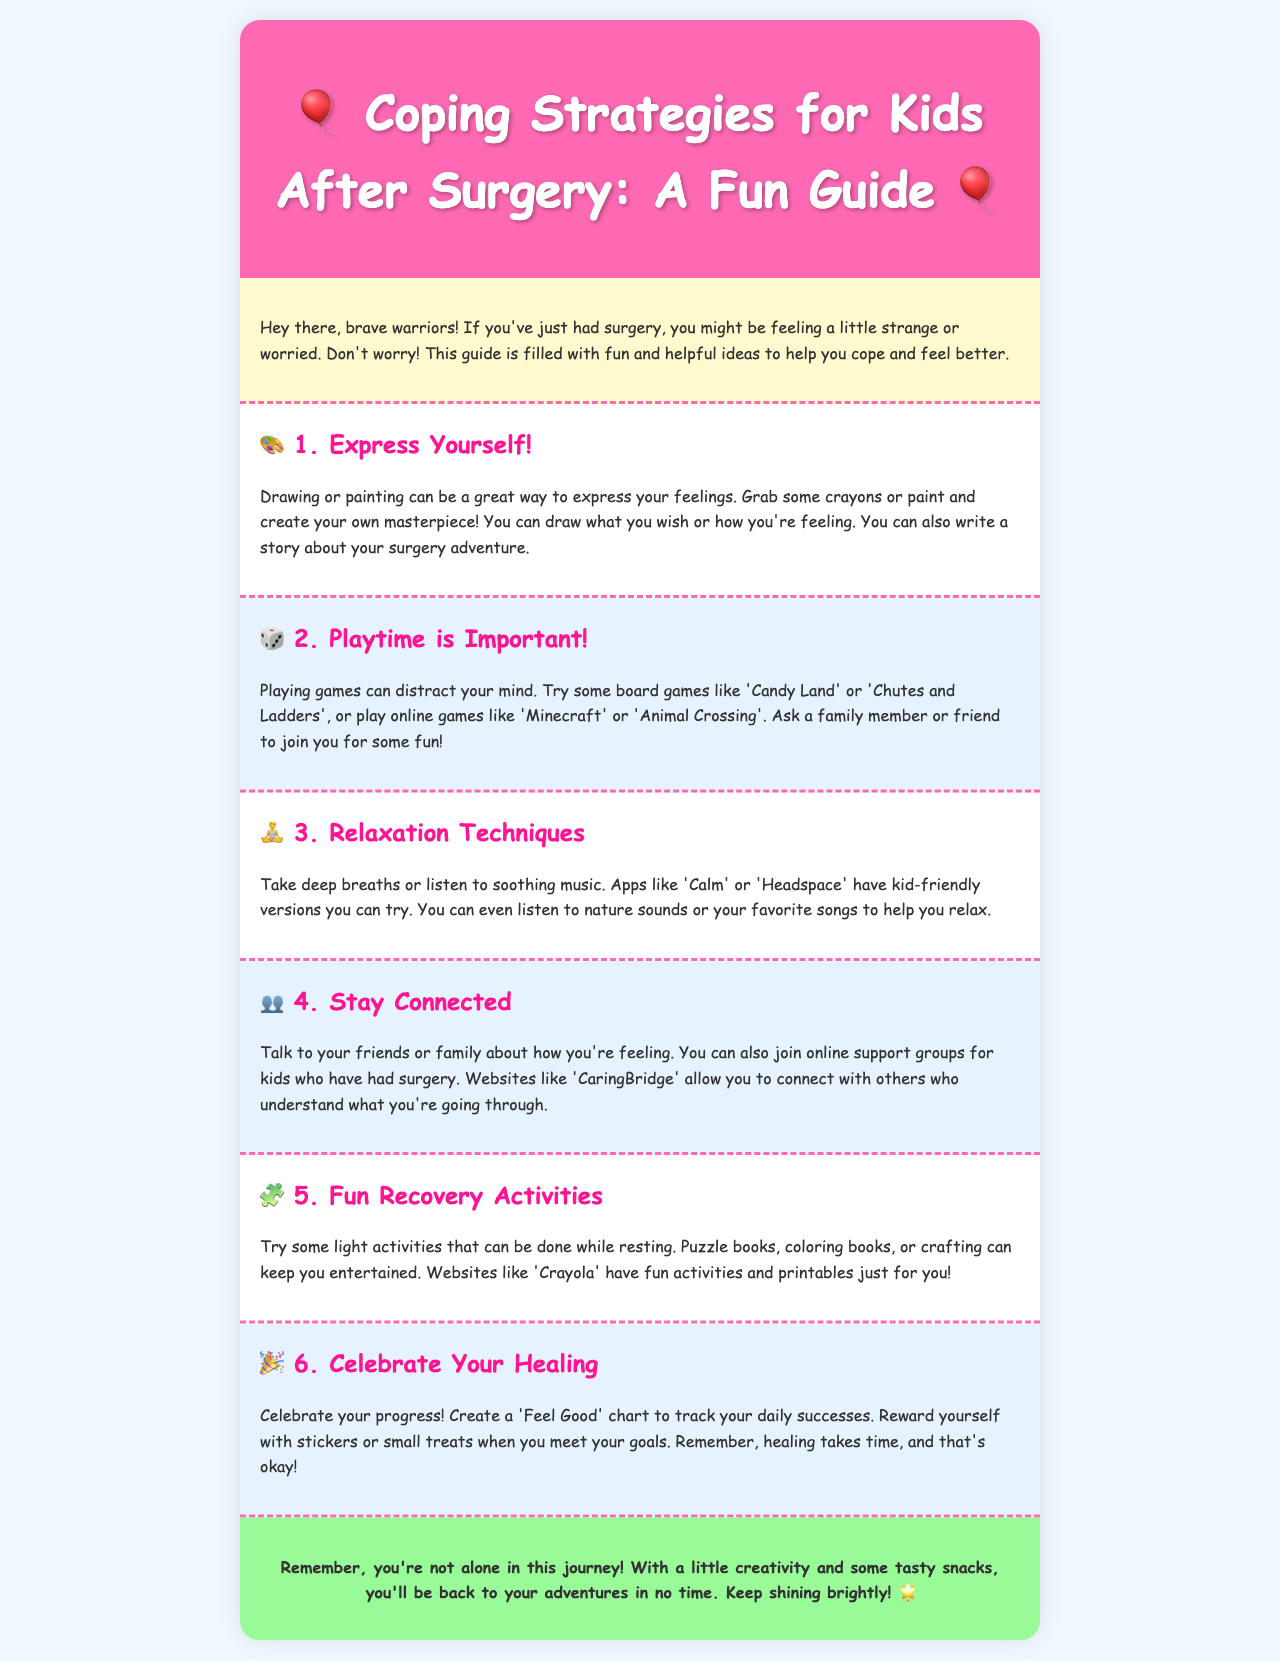What is the title of the guide? The title is stated at the top of the document in the header section.
Answer: Coping Strategies for Kids After Surgery: A Fun Guide How many main coping strategies are outlined? The number of strategies can be found by counting the sections listed in the document.
Answer: Six What symbol represents "Express Yourself"? Each section has an icon beside the title, indicating the corresponding activity.
Answer: 🎨 What kind of games are suggested for playtime? The document mentions specific types of games in the playtime section.
Answer: Board games and online games Which app is mentioned for relaxation techniques? The relaxation techniques section includes specific app names for assistance.
Answer: Calm What is suggested to track your healing progress? The document provides a specific method for tracking progress in the healing section.
Answer: Feel Good chart What color is the background of the container? The design of the document specifies the background color used for the container.
Answer: White Who should you talk to about how you're feeling? The stay connected section advises on whom to communicate feelings with.
Answer: Friends or family 